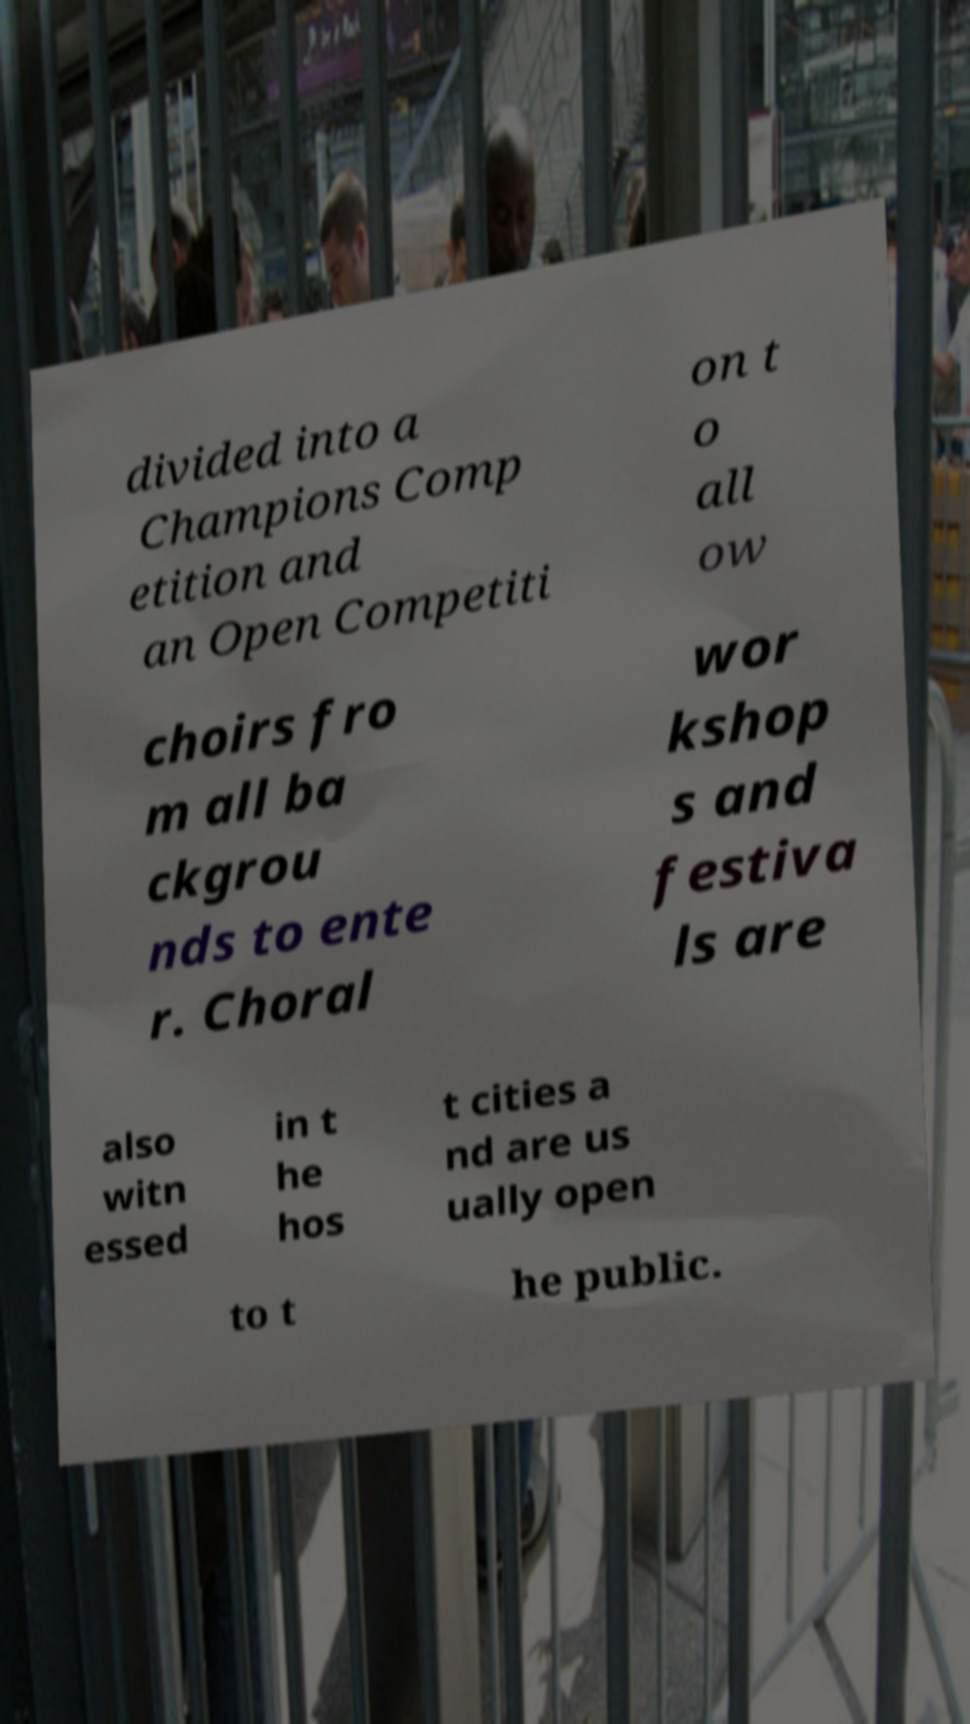Could you extract and type out the text from this image? divided into a Champions Comp etition and an Open Competiti on t o all ow choirs fro m all ba ckgrou nds to ente r. Choral wor kshop s and festiva ls are also witn essed in t he hos t cities a nd are us ually open to t he public. 